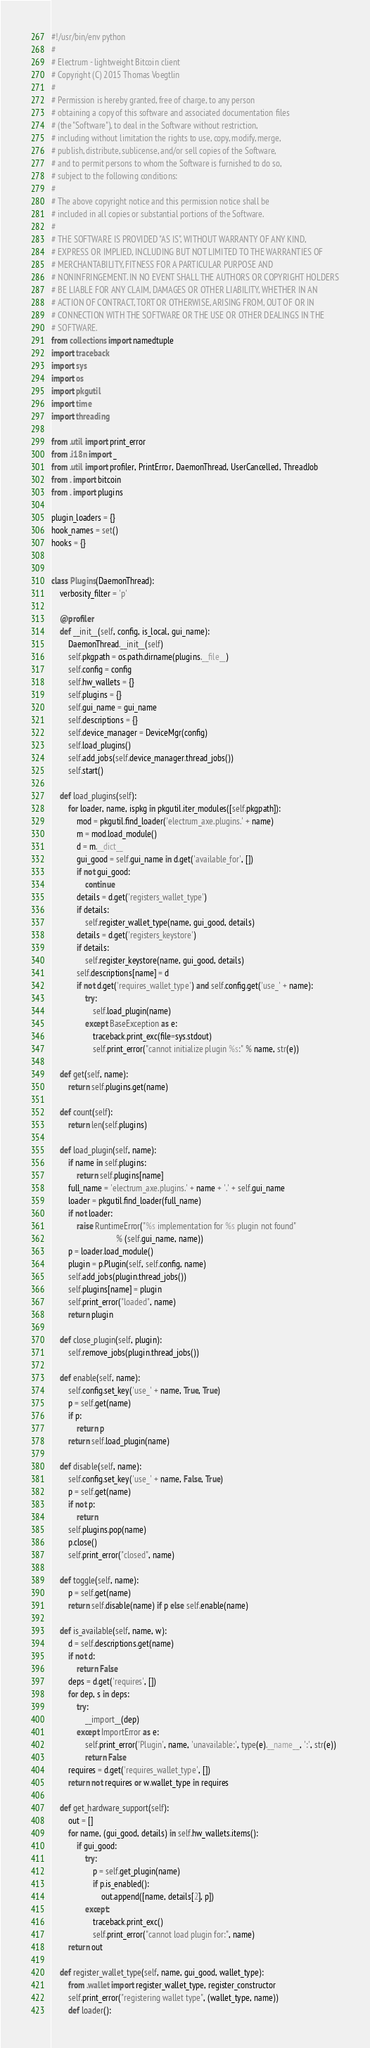Convert code to text. <code><loc_0><loc_0><loc_500><loc_500><_Python_>#!/usr/bin/env python
#
# Electrum - lightweight Bitcoin client
# Copyright (C) 2015 Thomas Voegtlin
#
# Permission is hereby granted, free of charge, to any person
# obtaining a copy of this software and associated documentation files
# (the "Software"), to deal in the Software without restriction,
# including without limitation the rights to use, copy, modify, merge,
# publish, distribute, sublicense, and/or sell copies of the Software,
# and to permit persons to whom the Software is furnished to do so,
# subject to the following conditions:
#
# The above copyright notice and this permission notice shall be
# included in all copies or substantial portions of the Software.
#
# THE SOFTWARE IS PROVIDED "AS IS", WITHOUT WARRANTY OF ANY KIND,
# EXPRESS OR IMPLIED, INCLUDING BUT NOT LIMITED TO THE WARRANTIES OF
# MERCHANTABILITY, FITNESS FOR A PARTICULAR PURPOSE AND
# NONINFRINGEMENT. IN NO EVENT SHALL THE AUTHORS OR COPYRIGHT HOLDERS
# BE LIABLE FOR ANY CLAIM, DAMAGES OR OTHER LIABILITY, WHETHER IN AN
# ACTION OF CONTRACT, TORT OR OTHERWISE, ARISING FROM, OUT OF OR IN
# CONNECTION WITH THE SOFTWARE OR THE USE OR OTHER DEALINGS IN THE
# SOFTWARE.
from collections import namedtuple
import traceback
import sys
import os
import pkgutil
import time
import threading

from .util import print_error
from .i18n import _
from .util import profiler, PrintError, DaemonThread, UserCancelled, ThreadJob
from . import bitcoin
from . import plugins

plugin_loaders = {}
hook_names = set()
hooks = {}


class Plugins(DaemonThread):
    verbosity_filter = 'p'

    @profiler
    def __init__(self, config, is_local, gui_name):
        DaemonThread.__init__(self)
        self.pkgpath = os.path.dirname(plugins.__file__)
        self.config = config
        self.hw_wallets = {}
        self.plugins = {}
        self.gui_name = gui_name
        self.descriptions = {}
        self.device_manager = DeviceMgr(config)
        self.load_plugins()
        self.add_jobs(self.device_manager.thread_jobs())
        self.start()

    def load_plugins(self):
        for loader, name, ispkg in pkgutil.iter_modules([self.pkgpath]):
            mod = pkgutil.find_loader('electrum_axe.plugins.' + name)
            m = mod.load_module()
            d = m.__dict__
            gui_good = self.gui_name in d.get('available_for', [])
            if not gui_good:
                continue
            details = d.get('registers_wallet_type')
            if details:
                self.register_wallet_type(name, gui_good, details)
            details = d.get('registers_keystore')
            if details:
                self.register_keystore(name, gui_good, details)
            self.descriptions[name] = d
            if not d.get('requires_wallet_type') and self.config.get('use_' + name):
                try:
                    self.load_plugin(name)
                except BaseException as e:
                    traceback.print_exc(file=sys.stdout)
                    self.print_error("cannot initialize plugin %s:" % name, str(e))

    def get(self, name):
        return self.plugins.get(name)

    def count(self):
        return len(self.plugins)

    def load_plugin(self, name):
        if name in self.plugins:
            return self.plugins[name]
        full_name = 'electrum_axe.plugins.' + name + '.' + self.gui_name
        loader = pkgutil.find_loader(full_name)
        if not loader:
            raise RuntimeError("%s implementation for %s plugin not found"
                               % (self.gui_name, name))
        p = loader.load_module()
        plugin = p.Plugin(self, self.config, name)
        self.add_jobs(plugin.thread_jobs())
        self.plugins[name] = plugin
        self.print_error("loaded", name)
        return plugin

    def close_plugin(self, plugin):
        self.remove_jobs(plugin.thread_jobs())

    def enable(self, name):
        self.config.set_key('use_' + name, True, True)
        p = self.get(name)
        if p:
            return p
        return self.load_plugin(name)

    def disable(self, name):
        self.config.set_key('use_' + name, False, True)
        p = self.get(name)
        if not p:
            return
        self.plugins.pop(name)
        p.close()
        self.print_error("closed", name)

    def toggle(self, name):
        p = self.get(name)
        return self.disable(name) if p else self.enable(name)

    def is_available(self, name, w):
        d = self.descriptions.get(name)
        if not d:
            return False
        deps = d.get('requires', [])
        for dep, s in deps:
            try:
                __import__(dep)
            except ImportError as e:
                self.print_error('Plugin', name, 'unavailable:', type(e).__name__, ':', str(e))
                return False
        requires = d.get('requires_wallet_type', [])
        return not requires or w.wallet_type in requires

    def get_hardware_support(self):
        out = []
        for name, (gui_good, details) in self.hw_wallets.items():
            if gui_good:
                try:
                    p = self.get_plugin(name)
                    if p.is_enabled():
                        out.append([name, details[2], p])
                except:
                    traceback.print_exc()
                    self.print_error("cannot load plugin for:", name)
        return out

    def register_wallet_type(self, name, gui_good, wallet_type):
        from .wallet import register_wallet_type, register_constructor
        self.print_error("registering wallet type", (wallet_type, name))
        def loader():</code> 